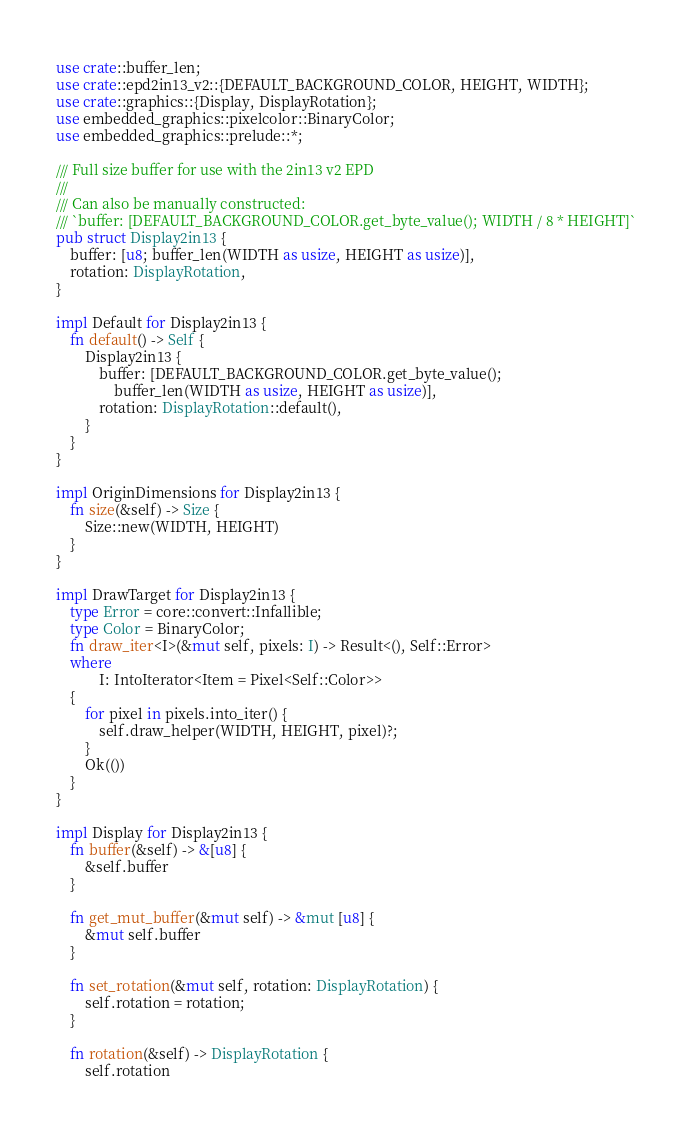Convert code to text. <code><loc_0><loc_0><loc_500><loc_500><_Rust_>use crate::buffer_len;
use crate::epd2in13_v2::{DEFAULT_BACKGROUND_COLOR, HEIGHT, WIDTH};
use crate::graphics::{Display, DisplayRotation};
use embedded_graphics::pixelcolor::BinaryColor;
use embedded_graphics::prelude::*;

/// Full size buffer for use with the 2in13 v2 EPD
///
/// Can also be manually constructed:
/// `buffer: [DEFAULT_BACKGROUND_COLOR.get_byte_value(); WIDTH / 8 * HEIGHT]`
pub struct Display2in13 {
    buffer: [u8; buffer_len(WIDTH as usize, HEIGHT as usize)],
    rotation: DisplayRotation,
}

impl Default for Display2in13 {
    fn default() -> Self {
        Display2in13 {
            buffer: [DEFAULT_BACKGROUND_COLOR.get_byte_value();
                buffer_len(WIDTH as usize, HEIGHT as usize)],
            rotation: DisplayRotation::default(),
        }
    }
}

impl OriginDimensions for Display2in13 {
    fn size(&self) -> Size {
        Size::new(WIDTH, HEIGHT)
    }
}

impl DrawTarget for Display2in13 {
    type Error = core::convert::Infallible;
    type Color = BinaryColor;
    fn draw_iter<I>(&mut self, pixels: I) -> Result<(), Self::Error>
    where
            I: IntoIterator<Item = Pixel<Self::Color>>
    {
        for pixel in pixels.into_iter() {
            self.draw_helper(WIDTH, HEIGHT, pixel)?;
        }
        Ok(())
    }
}

impl Display for Display2in13 {
    fn buffer(&self) -> &[u8] {
        &self.buffer
    }

    fn get_mut_buffer(&mut self) -> &mut [u8] {
        &mut self.buffer
    }

    fn set_rotation(&mut self, rotation: DisplayRotation) {
        self.rotation = rotation;
    }

    fn rotation(&self) -> DisplayRotation {
        self.rotation</code> 